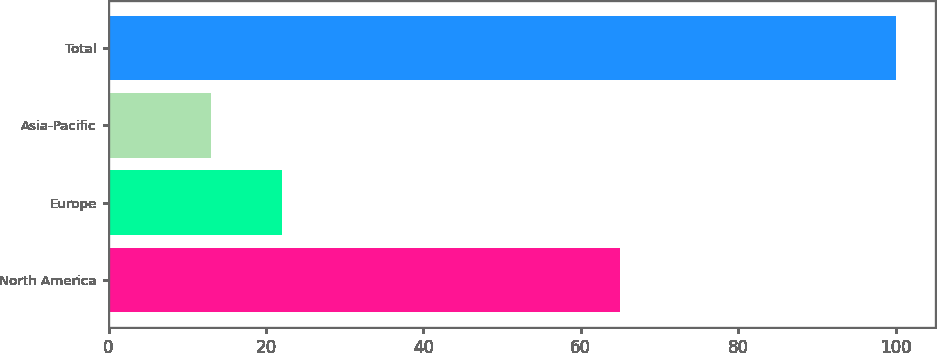<chart> <loc_0><loc_0><loc_500><loc_500><bar_chart><fcel>North America<fcel>Europe<fcel>Asia-Pacific<fcel>Total<nl><fcel>65<fcel>22<fcel>13<fcel>100<nl></chart> 